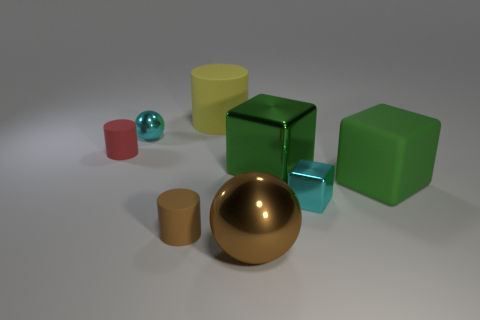Subtract all green blocks. How many were subtracted if there are1green blocks left? 1 Subtract all shiny cubes. How many cubes are left? 1 Subtract all yellow cylinders. How many cylinders are left? 2 Add 2 cylinders. How many objects exist? 10 Subtract all blocks. How many objects are left? 5 Subtract 3 blocks. How many blocks are left? 0 Subtract 0 gray blocks. How many objects are left? 8 Subtract all purple cubes. Subtract all blue spheres. How many cubes are left? 3 Subtract all red balls. How many green blocks are left? 2 Subtract all green metal blocks. Subtract all tiny green shiny cylinders. How many objects are left? 7 